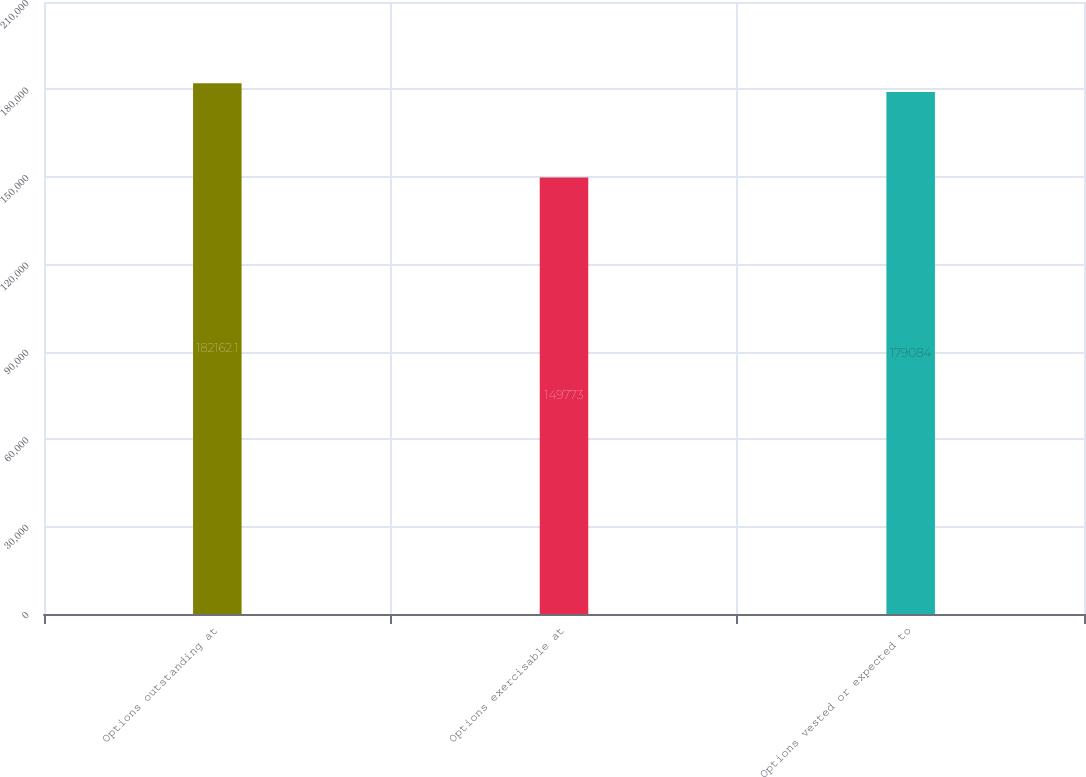Convert chart. <chart><loc_0><loc_0><loc_500><loc_500><bar_chart><fcel>Options outstanding at<fcel>Options exercisable at<fcel>Options vested or expected to<nl><fcel>182162<fcel>149773<fcel>179084<nl></chart> 